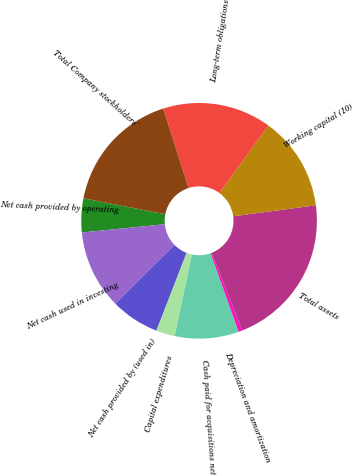Convert chart. <chart><loc_0><loc_0><loc_500><loc_500><pie_chart><fcel>Net cash provided by operating<fcel>Net cash used in investing<fcel>Net cash provided by (used in)<fcel>Capital expenditures<fcel>Cash paid for acquisitions net<fcel>Depreciation and amortization<fcel>Total assets<fcel>Working capital (10)<fcel>Long-term obligations<fcel>Total Company stockholders'<nl><fcel>4.64%<fcel>10.82%<fcel>6.7%<fcel>2.58%<fcel>8.76%<fcel>0.52%<fcel>21.12%<fcel>12.88%<fcel>14.94%<fcel>17.0%<nl></chart> 